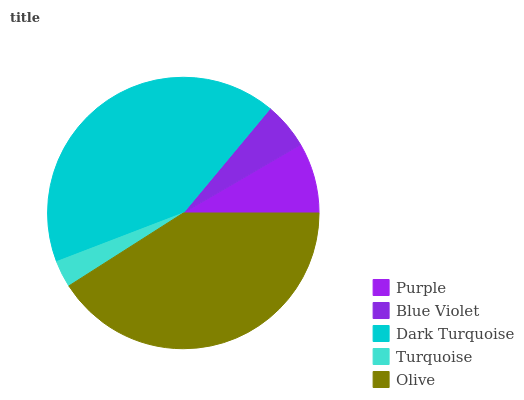Is Turquoise the minimum?
Answer yes or no. Yes. Is Dark Turquoise the maximum?
Answer yes or no. Yes. Is Blue Violet the minimum?
Answer yes or no. No. Is Blue Violet the maximum?
Answer yes or no. No. Is Purple greater than Blue Violet?
Answer yes or no. Yes. Is Blue Violet less than Purple?
Answer yes or no. Yes. Is Blue Violet greater than Purple?
Answer yes or no. No. Is Purple less than Blue Violet?
Answer yes or no. No. Is Purple the high median?
Answer yes or no. Yes. Is Purple the low median?
Answer yes or no. Yes. Is Blue Violet the high median?
Answer yes or no. No. Is Olive the low median?
Answer yes or no. No. 